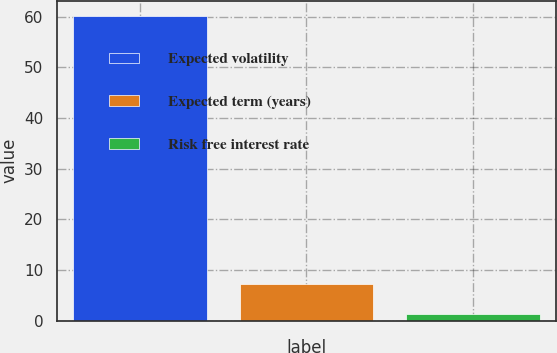Convert chart to OTSL. <chart><loc_0><loc_0><loc_500><loc_500><bar_chart><fcel>Expected volatility<fcel>Expected term (years)<fcel>Risk free interest rate<nl><fcel>60.16<fcel>7.19<fcel>1.3<nl></chart> 